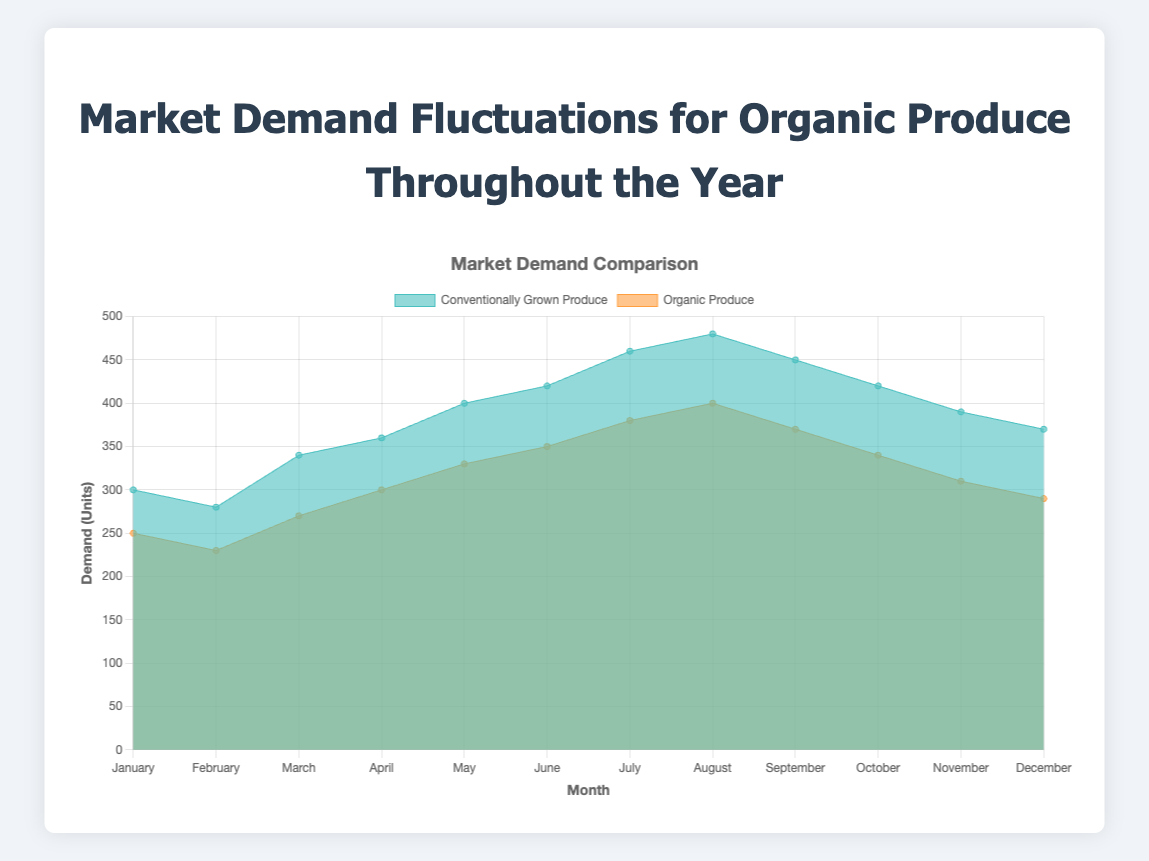Which month has the highest demand for organic produce? By looking at the organic produce data points across the year, we see that August has the highest demand with 400 units.
Answer: August What's the difference in demand for organic produce between July and August? From the chart, the demand in July is 380 units and in August is 400 units. The difference is 400 - 380 = 20 units.
Answer: 20 units In which month is the demand for conventionally grown produce the lowest? By checking the data for each month, January has the lowest demand for conventionally grown produce at 300 units.
Answer: January What's the average demand for organically grown produce over the first half of the year? Calculate the average of January through June for organic produce (250 + 230 + 270 + 300 + 330 + 350) / 6 = 1730 / 6 = 288.33 units.
Answer: 288.33 units During which month is there the smallest gap between conventionally grown produce and organic produce demand? The smallest difference can be found by subtracting the organic produce demand from conventionally grown produce demand for each month. The data indicate that January, with a difference of 300 - 250 = 50 units, has the smallest gap.
Answer: January Identify the trend for demand in organic produce from May to August. Observing the chart, the demand for organic produce shows an increasing trend from May (330 units) to August (400 units).
Answer: Increasing trend Are there months where the demand for conventionally grown produce decreases consecutively? If so, which months? The demand decreases consecutively from August (480 units) to September (450 units) and further to October (420 units).
Answer: August to October Which month shows the greatest increase in demand for organic produce compared to the previous month? The greatest increase can be observed by calculating demand changes each month. From April to May, the demand increased by 330 - 300 = 30 units. This is the largest increase.
Answer: May What is the cumulative demand for conventionally grown produce from June to August? Sum the demand from June (420 units), July (460 units), and August (480 units) to get 420 + 460 + 480 = 1360 units.
Answer: 1360 units Is there any month where the demand for organic produce surpasses 350 units and what month is it? By inspecting the chart, organic produce surpasses 350 units in July (380 units) and August (400 units).
Answer: July and August 